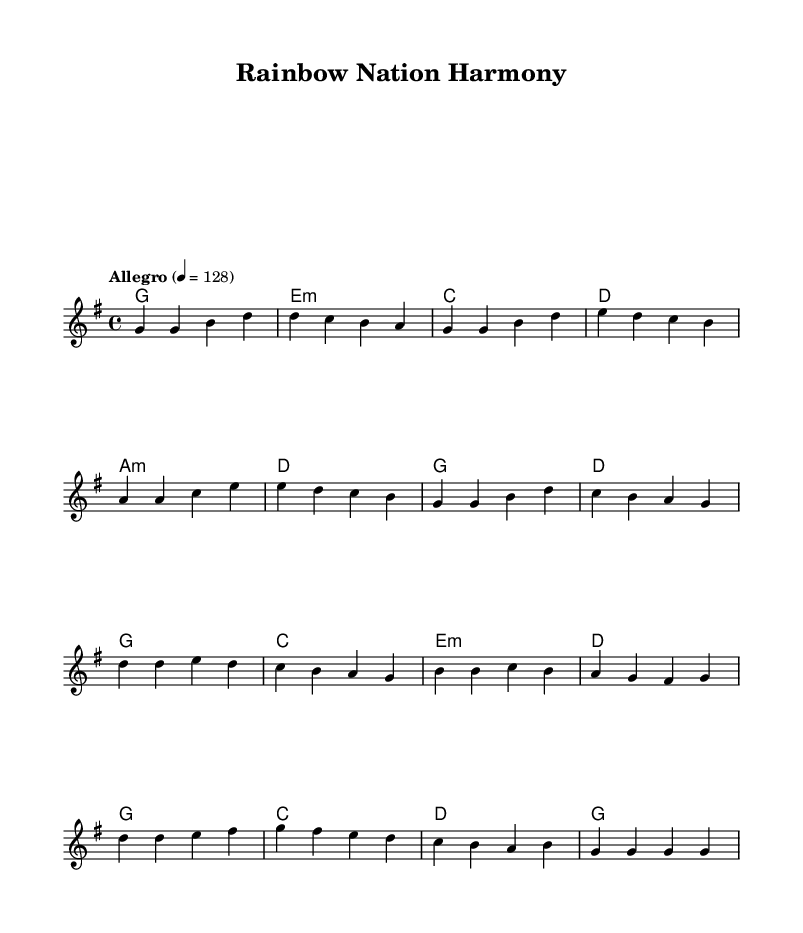What is the key signature of this music? The key signature is G major, which has one sharp (F#). This can be seen right at the beginning of the sheet music in the key signature section.
Answer: G major What is the time signature of this music? The time signature is 4/4, meaning there are four beats in each measure. This is indicated at the start of the sheet music before the notes begin.
Answer: 4/4 What is the tempo marking of this piece? The tempo marking is "Allegro", which indicates a fast and lively pace, specifically at a quarter note equals 128 beats per minute. The tempo is noted at the top of the score.
Answer: Allegro How many measures are there in the verse section? There are 8 measures in the verse section. By counting each grouping of notes from the beginning of the verse in the score, we can determine this total.
Answer: 8 What is the main theme of the lyrics? The main theme of the lyrics celebrates diversity and unity. By analyzing the lyrics present in the score, they focus on being united and celebrating differences in a multicultural society.
Answer: Diversity and unity What musical form does this piece represent? This piece represents a verse-chorus structure, which is common in K-Pop music. This can be identified by the distinct sections labeled as 'Verse' and 'Chorus' in the score.
Answer: Verse-chorus What is the overall message conveyed through this song's title and lyrics? The overall message conveys a sense of harmony and togetherness in celebrating a multicultural society, as reflected in the title "Rainbow Nation Harmony" and the corresponding lyrics. This thematic analysis can be derived from both the title and lyrical content.
Answer: Harmony and togetherness 